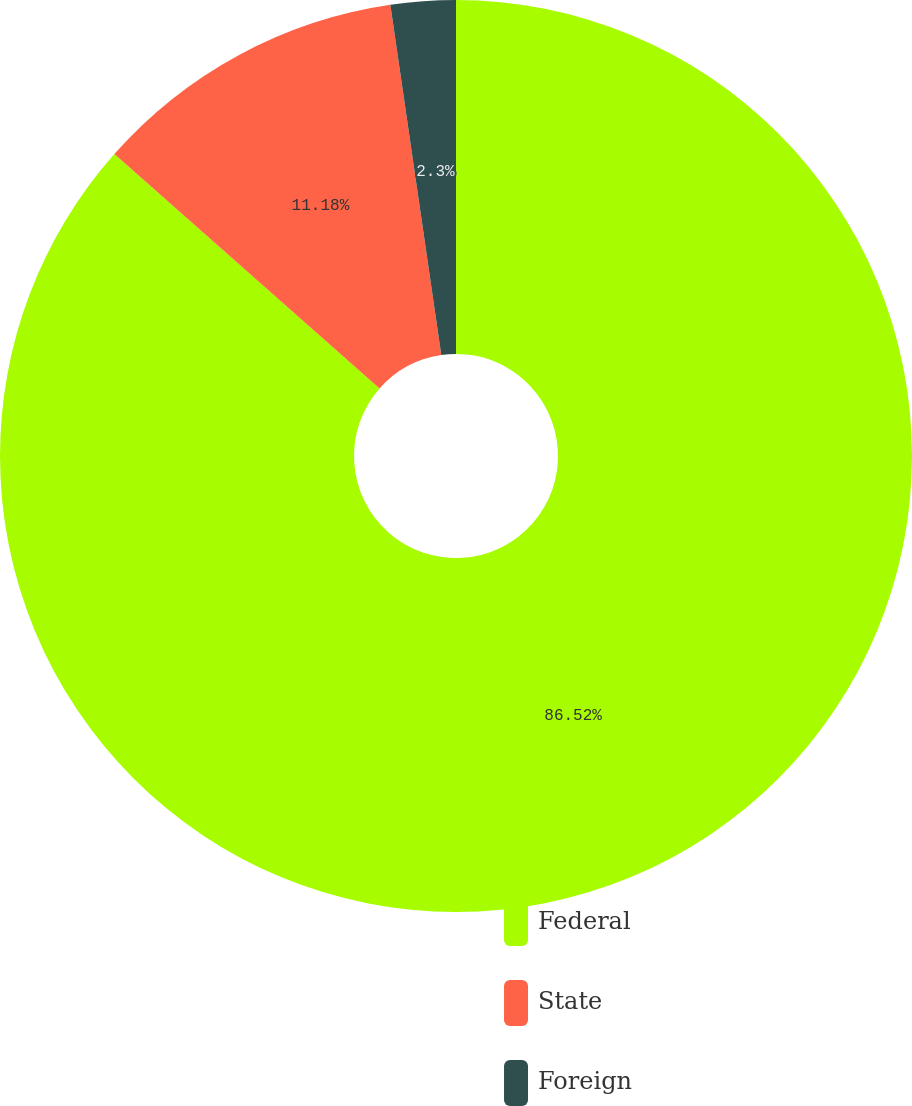Convert chart. <chart><loc_0><loc_0><loc_500><loc_500><pie_chart><fcel>Federal<fcel>State<fcel>Foreign<nl><fcel>86.52%<fcel>11.18%<fcel>2.3%<nl></chart> 